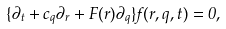Convert formula to latex. <formula><loc_0><loc_0><loc_500><loc_500>\{ \partial _ { t } + { c _ { q } } \partial _ { r } + { F } ( { r } ) \partial _ { q } \} f ( { r } , { q } , t ) = 0 ,</formula> 